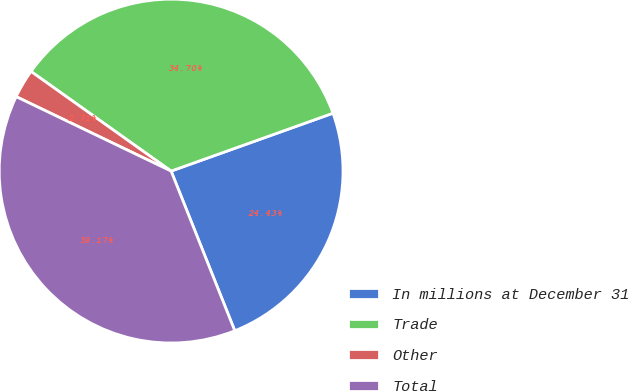<chart> <loc_0><loc_0><loc_500><loc_500><pie_chart><fcel>In millions at December 31<fcel>Trade<fcel>Other<fcel>Total<nl><fcel>24.43%<fcel>34.7%<fcel>2.71%<fcel>38.17%<nl></chart> 